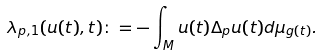<formula> <loc_0><loc_0><loc_500><loc_500>\lambda _ { p , 1 } ( u ( t ) , t ) \colon = - \int _ { M } u ( t ) \Delta _ { p } u ( t ) d \mu _ { g ( t ) } .</formula> 